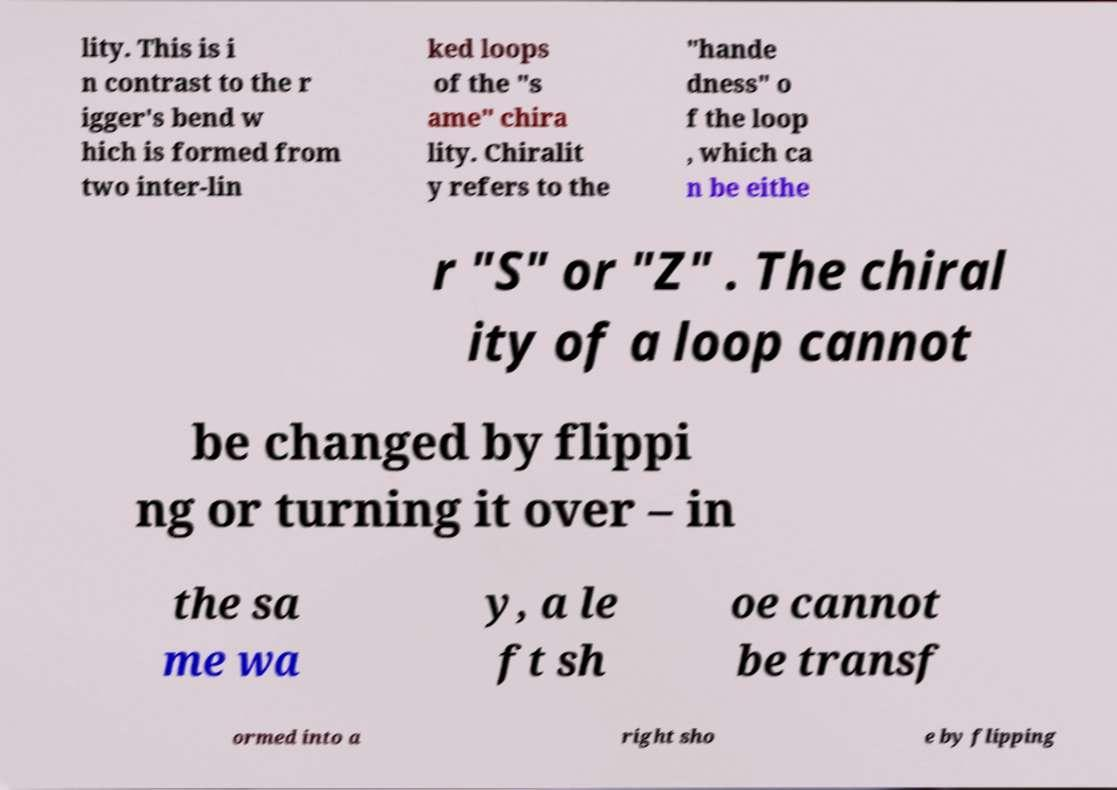There's text embedded in this image that I need extracted. Can you transcribe it verbatim? lity. This is i n contrast to the r igger's bend w hich is formed from two inter-lin ked loops of the "s ame" chira lity. Chiralit y refers to the "hande dness" o f the loop , which ca n be eithe r "S" or "Z" . The chiral ity of a loop cannot be changed by flippi ng or turning it over – in the sa me wa y, a le ft sh oe cannot be transf ormed into a right sho e by flipping 